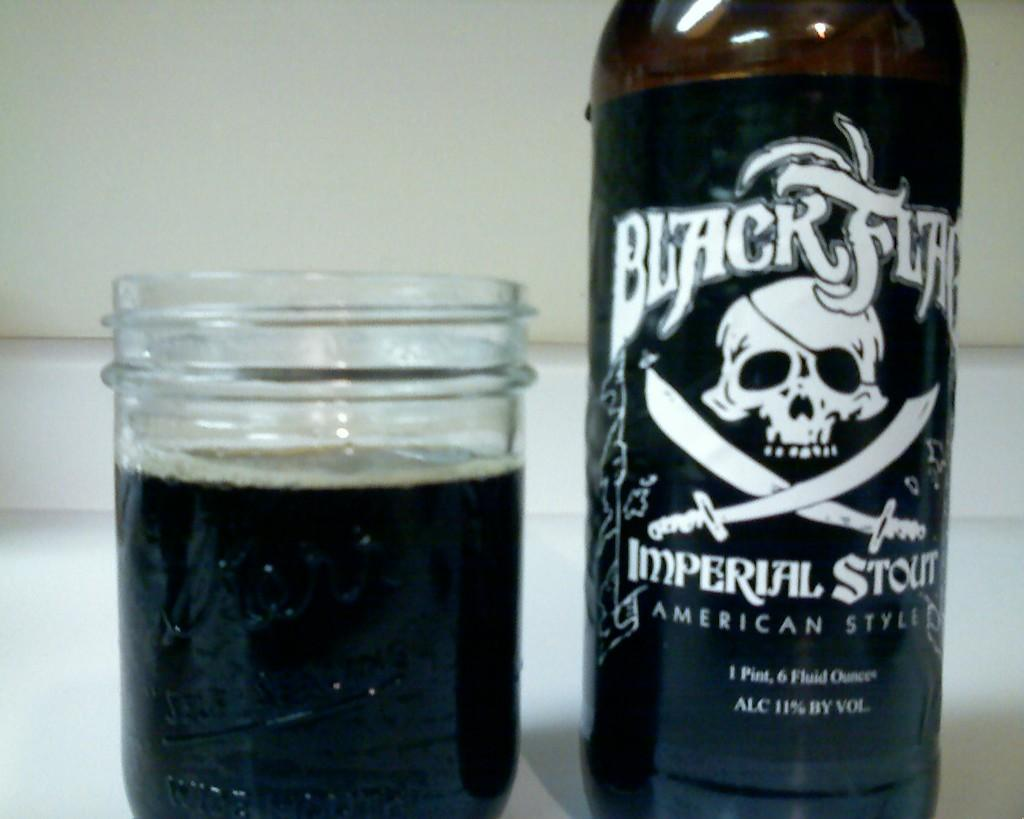<image>
Offer a succinct explanation of the picture presented. A glass of dark ale sits next to a bottle of Black Flag Imperial Stout. 